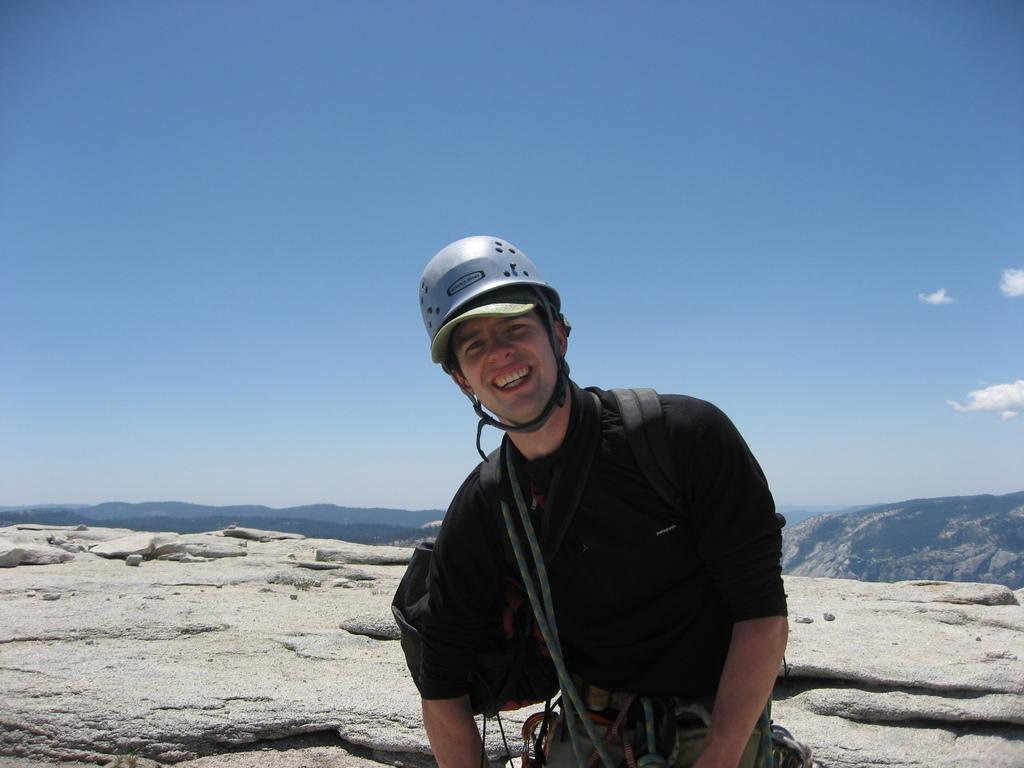What is the person in the image wearing on their head? The person is wearing a helmet. What color is the T-shirt the person is wearing? The person is wearing a black T-shirt. What is the person carrying in the image? The person is carrying a bag. Where is the person standing in the image? The person is standing on a mountain. What can be seen in the background of the image? There are mountains visible in the background of the image, and the sky is clear. What type of yak can be seen performing an operation on the mountain in the image? There is no yak present in the image, nor is there any operation being performed. What kind of rail can be seen connecting the mountains in the image? There is: There is no rail visible in the image; the person is standing on a mountain with no visible connections to other mountains. 